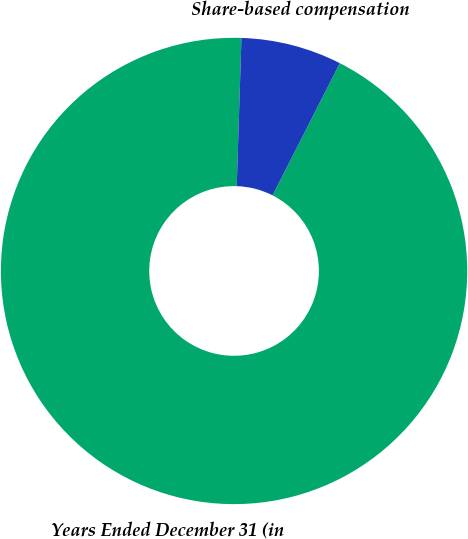Convert chart to OTSL. <chart><loc_0><loc_0><loc_500><loc_500><pie_chart><fcel>Years Ended December 31 (in<fcel>Share-based compensation<nl><fcel>93.01%<fcel>6.99%<nl></chart> 